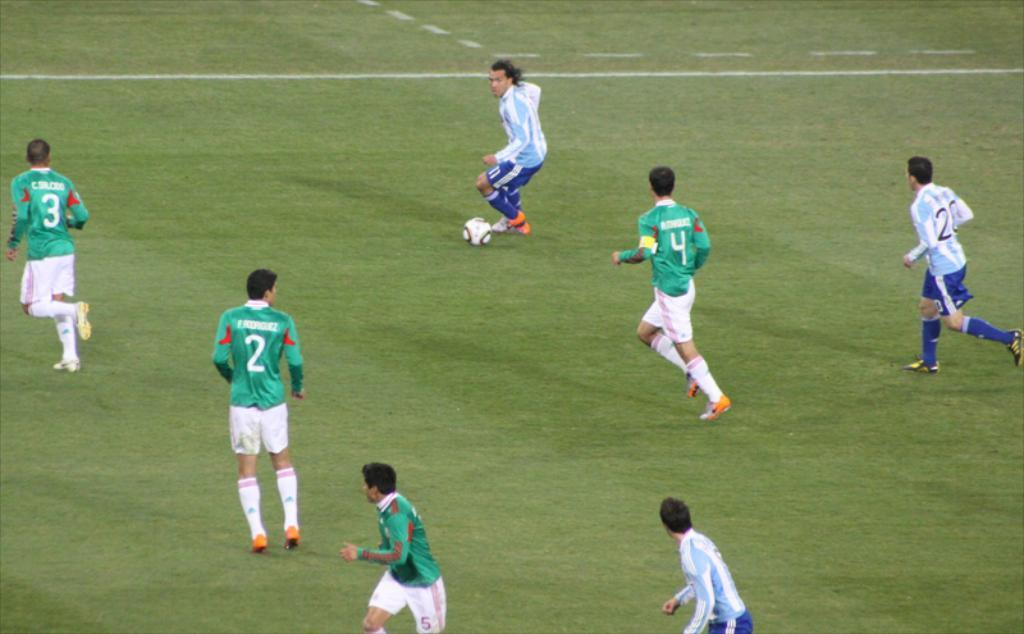What is happening in the image involving multiple people? There is a group of players in the image. Where are the players located? The players are on the ground. What action is one of the players about to perform? One player is about to kick a ball. Can you describe the position of the ball in relation to the player? The ball is in front of the player. What is the plot of the story being told in the image? There is no story being told in the image; it is a snapshot of a moment in time involving a group of players and a ball. 